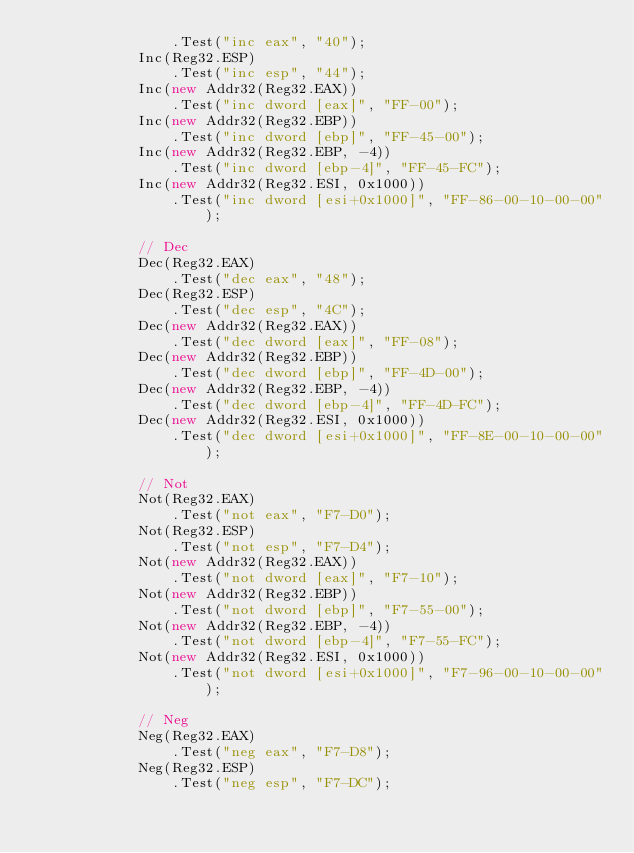Convert code to text. <code><loc_0><loc_0><loc_500><loc_500><_C#_>                .Test("inc eax", "40");
            Inc(Reg32.ESP)
                .Test("inc esp", "44");
            Inc(new Addr32(Reg32.EAX))
                .Test("inc dword [eax]", "FF-00");
            Inc(new Addr32(Reg32.EBP))
                .Test("inc dword [ebp]", "FF-45-00");
            Inc(new Addr32(Reg32.EBP, -4))
                .Test("inc dword [ebp-4]", "FF-45-FC");
            Inc(new Addr32(Reg32.ESI, 0x1000))
                .Test("inc dword [esi+0x1000]", "FF-86-00-10-00-00");

            // Dec
            Dec(Reg32.EAX)
                .Test("dec eax", "48");
            Dec(Reg32.ESP)
                .Test("dec esp", "4C");
            Dec(new Addr32(Reg32.EAX))
                .Test("dec dword [eax]", "FF-08");
            Dec(new Addr32(Reg32.EBP))
                .Test("dec dword [ebp]", "FF-4D-00");
            Dec(new Addr32(Reg32.EBP, -4))
                .Test("dec dword [ebp-4]", "FF-4D-FC");
            Dec(new Addr32(Reg32.ESI, 0x1000))
                .Test("dec dword [esi+0x1000]", "FF-8E-00-10-00-00");

            // Not
            Not(Reg32.EAX)
                .Test("not eax", "F7-D0");
            Not(Reg32.ESP)
                .Test("not esp", "F7-D4");
            Not(new Addr32(Reg32.EAX))
                .Test("not dword [eax]", "F7-10");
            Not(new Addr32(Reg32.EBP))
                .Test("not dword [ebp]", "F7-55-00");
            Not(new Addr32(Reg32.EBP, -4))
                .Test("not dword [ebp-4]", "F7-55-FC");
            Not(new Addr32(Reg32.ESI, 0x1000))
                .Test("not dword [esi+0x1000]", "F7-96-00-10-00-00");

            // Neg
            Neg(Reg32.EAX)
                .Test("neg eax", "F7-D8");
            Neg(Reg32.ESP)
                .Test("neg esp", "F7-DC");</code> 